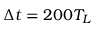<formula> <loc_0><loc_0><loc_500><loc_500>\Delta t = 2 0 0 T _ { L }</formula> 